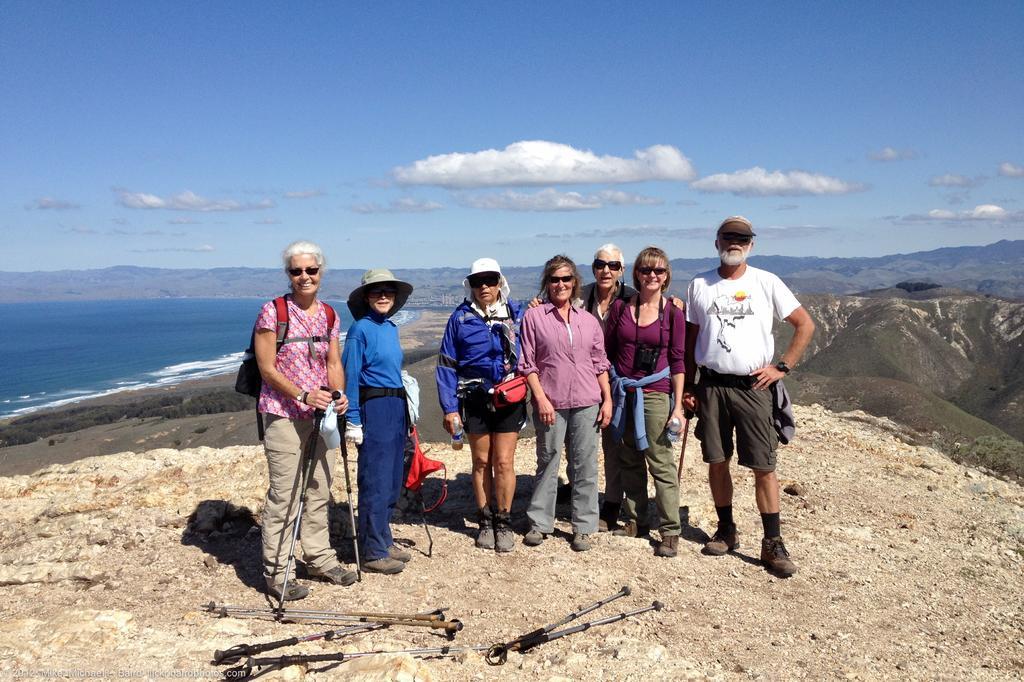In one or two sentences, can you explain what this image depicts? Front these people are standing and wore goggles. This person wore a bag and holding a stand. Background we can see water, hills and sky. These are clouds. 